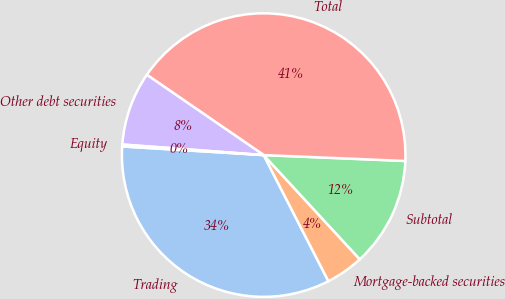Convert chart. <chart><loc_0><loc_0><loc_500><loc_500><pie_chart><fcel>Trading<fcel>Mortgage-backed securities<fcel>Subtotal<fcel>Total<fcel>Other debt securities<fcel>Equity<nl><fcel>33.52%<fcel>4.31%<fcel>12.48%<fcel>41.09%<fcel>8.39%<fcel>0.22%<nl></chart> 